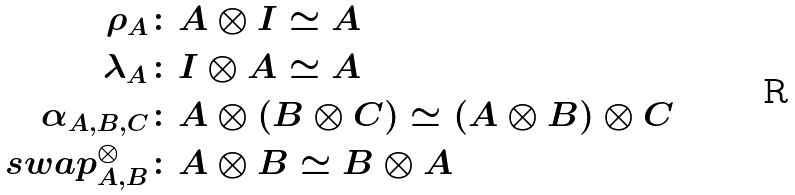Convert formula to latex. <formula><loc_0><loc_0><loc_500><loc_500>\rho _ { A } & \colon A \otimes I \simeq A \\ \lambda _ { A } & \colon I \otimes A \simeq A \\ \alpha _ { A , B , C } & \colon A \otimes ( B \otimes C ) \simeq ( A \otimes B ) \otimes C \\ s w a p ^ { \otimes } _ { A , B } & \colon A \otimes B \simeq B \otimes A</formula> 